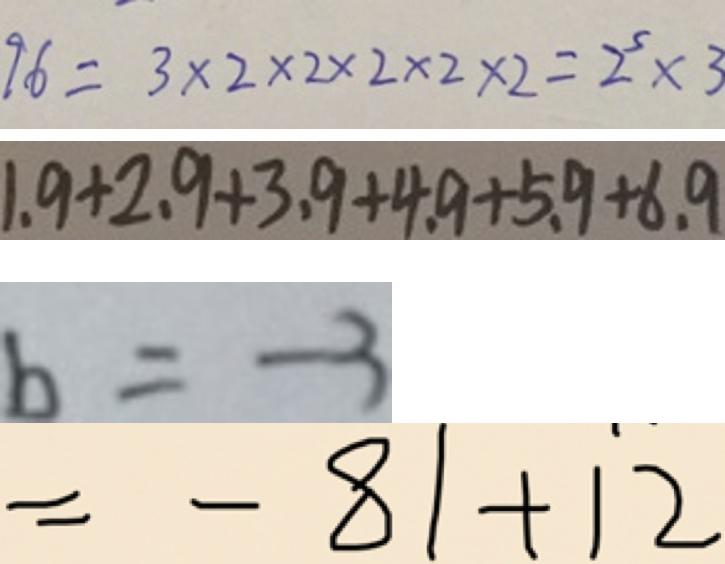<formula> <loc_0><loc_0><loc_500><loc_500>9 6 = 3 \times 2 \times 2 \times 2 \times 2 \times 2 = 2 ^ { 5 } \times 3 
 1 . 9 + 2 . 9 + 3 . 9 + 4 . 9 + 5 . 9 + 6 . 9 
 b = - 3 
 = - 8 1 + 1 2</formula> 